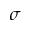<formula> <loc_0><loc_0><loc_500><loc_500>\sigma</formula> 